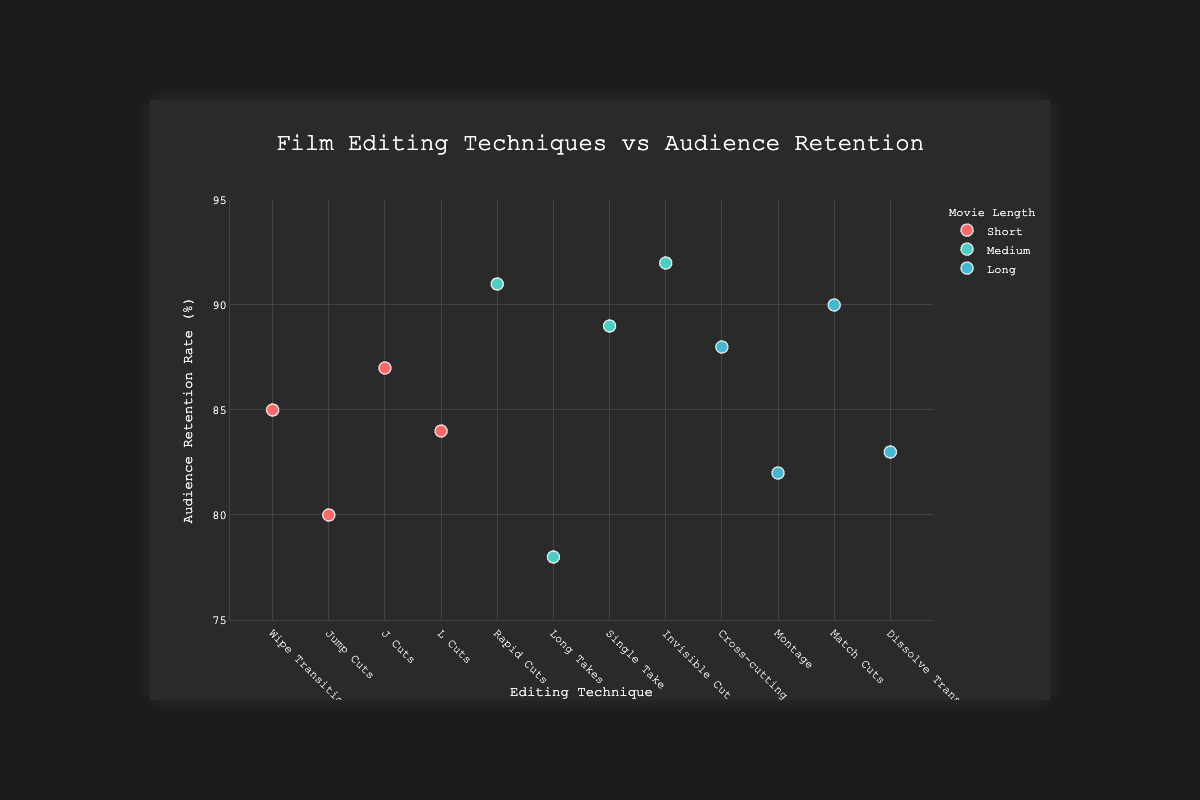What's the title of the plot? The title of the plot is explicitly stated at the top of the figure.
Answer: Film Editing Techniques vs Audience Retention What are the labels of the x-axis and y-axis? The labels of the axes are given by their titles.
Answer: Editing Technique (x-axis), Audience Retention Rate (%) (y-axis) Which editing technique is associated with the highest audience retention rate in a medium-length movie? By examining the figure, look for the highest point within the 'Medium' category and note the corresponding editing technique.
Answer: Invisible Cut What is the average audience retention rate for movies categorized with short lengths? Identify the data points for 'Short' movies, sum their retention rates (85 + 80 + 87 + 84), and divide by the number of data points. (85 + 80 + 87 + 84) / 4 = 84
Answer: 84 Compare the audience retention rates between 'Cross-cutting' and 'Montage' techniques in long movies. Which technique has a higher retention rate? Locate the data points for 'Cross-cutting' (88) and 'Montage' (82) in long movies and compare their values.
Answer: Cross-cutting How many different editing techniques are used in the plot? Count the unique entries in the 'Editing Technique' category across all data points.
Answer: 11 Which editing technique achieves a retention rate above 90% in a medium-length movie? Filter the medium-length movies and check which technique has a retention rate above 90%.
Answer: Rapid Cuts and Invisible Cut What is the overall trend of audience retention rates for long movies? Analyze the retention rates for long movie entries (88, 82, 90, 83) to determine if they are generally high or low.
Answer: Generally, high If you combine the audience retention rates of all the short movies, what is the total? Sum up the retention rates of short movies (85 + 80 + 87 + 84).
Answer: 336 Which movie length category seems to have more variability in audience retention rates? Compare the spread of retention rates within each movie length category to see which has the most variability.
Answer: Medium 